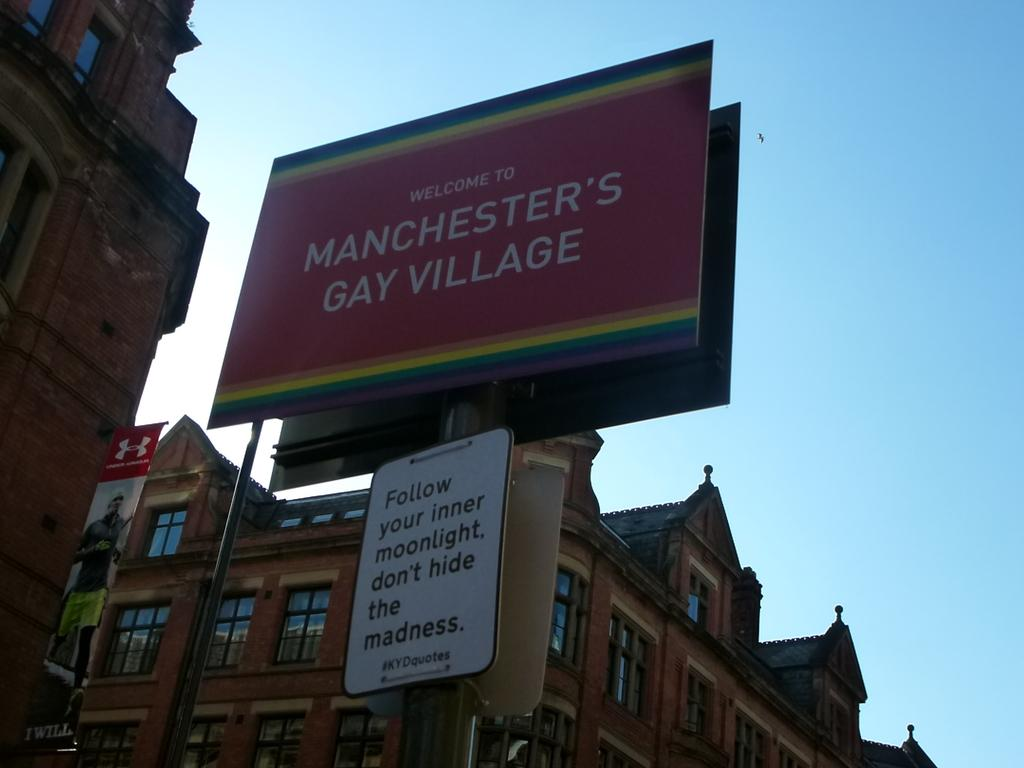<image>
Render a clear and concise summary of the photo. A rainbow sign on the street that reads Welcome to Manchster's Gay Village. 